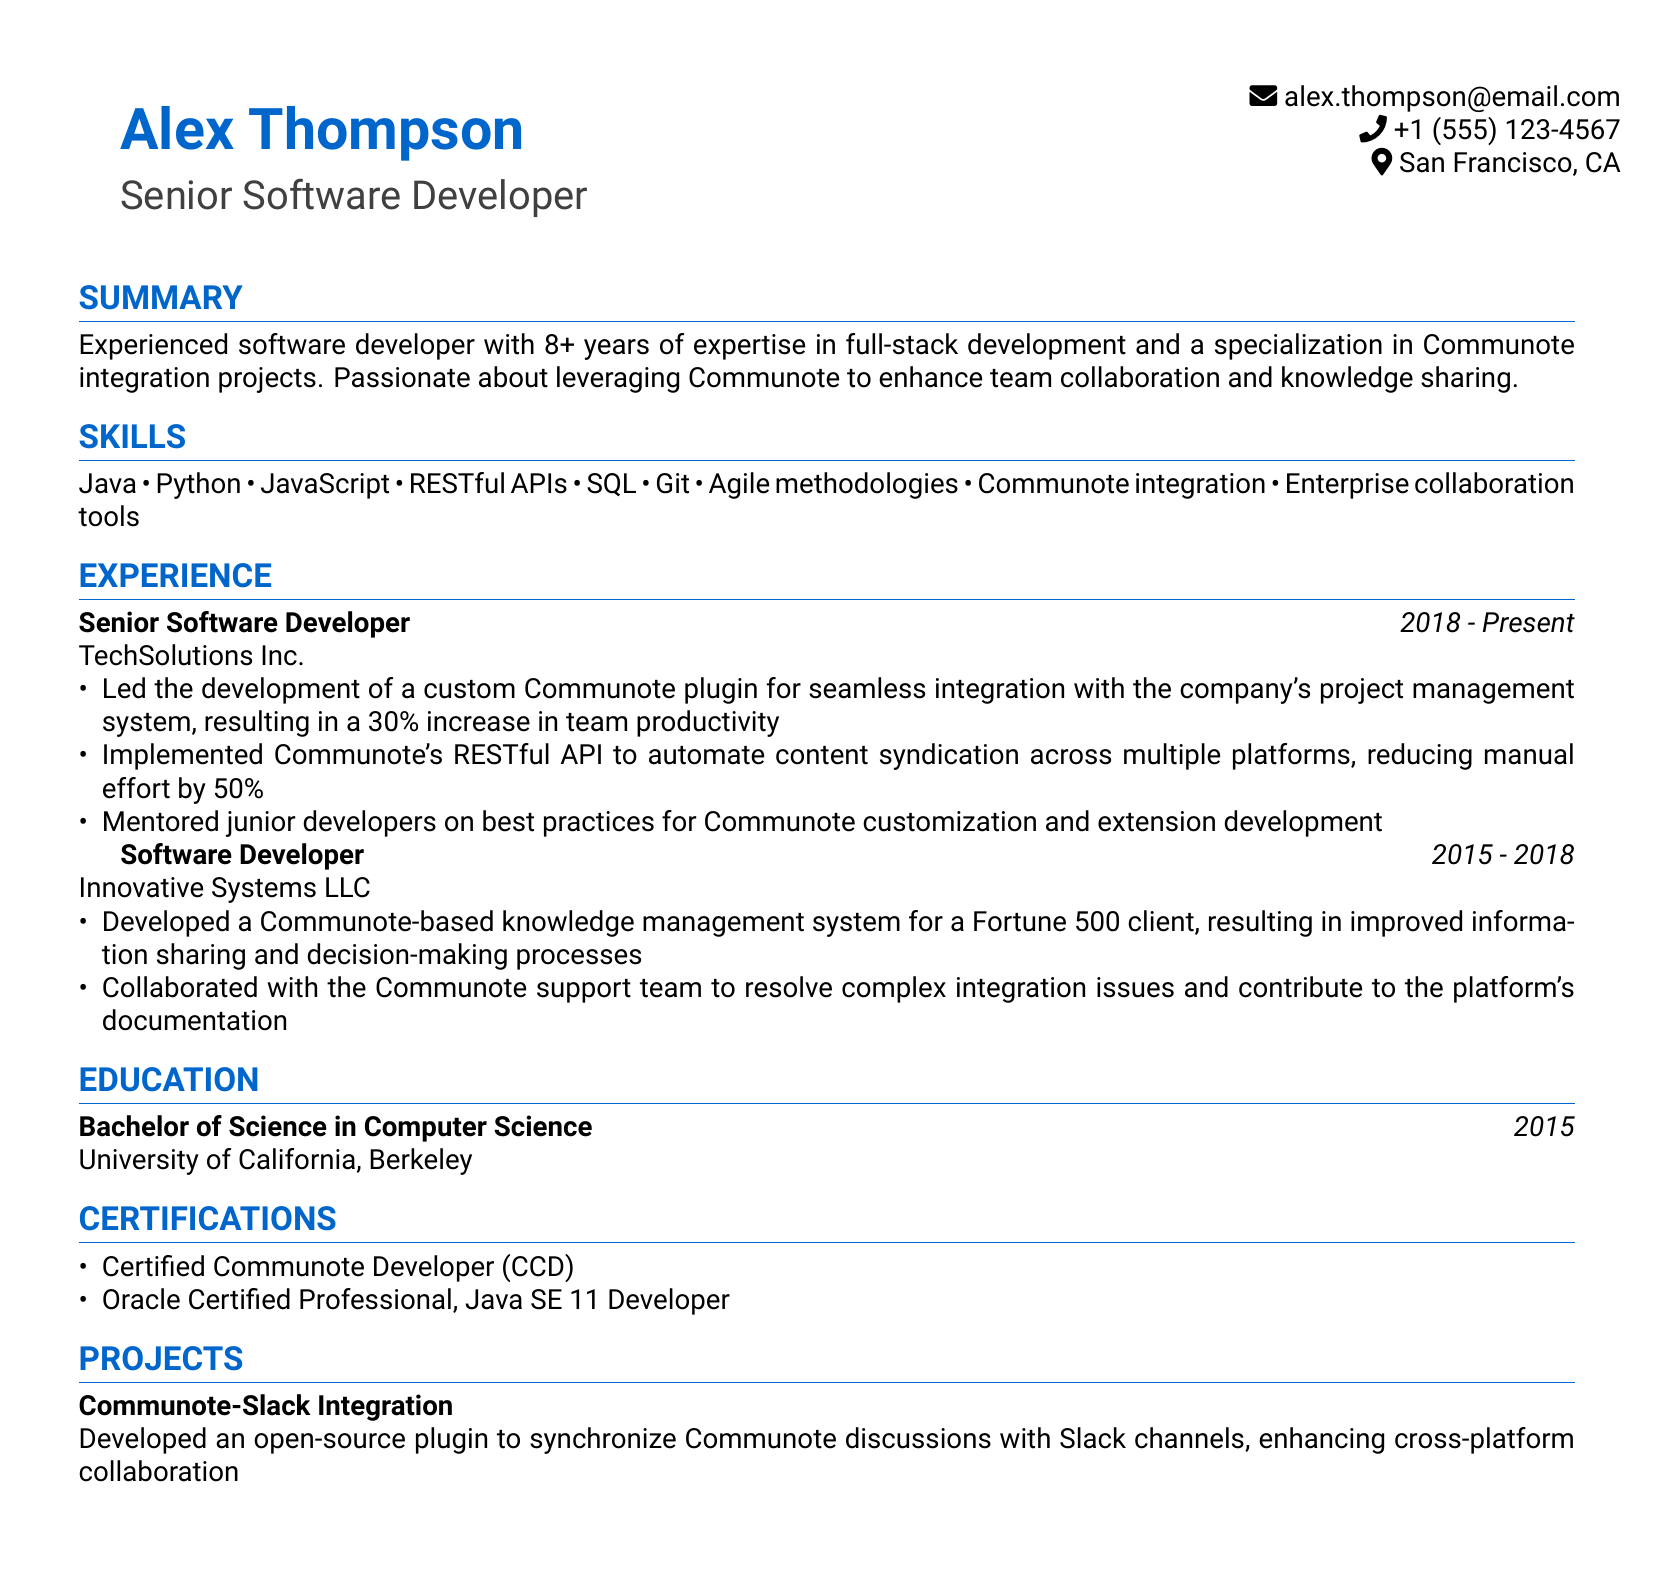What is the name of the individual? The name of the individual is listed at the top of the document.
Answer: Alex Thompson What is the title of the CV? The title reflects the individual's professional position and is indicated below the name.
Answer: Senior Software Developer How many years of experience does Alex have? The summary section states the years of expertise Alex possesses in the industry.
Answer: 8+ What company does Alex currently work for? The experience section lists the current employer in the first entry.
Answer: TechSolutions Inc What was the duration of Alex's previous job? The experience section provides the period Alex worked at the prior company.
Answer: 2015 - 2018 What is one of the certifications Alex holds? The certifications section lists various qualifications Alex has achieved.
Answer: Certified Communote Developer (CCD) What project did Alex develop related to Communote? The projects section highlights significant work performed by Alex.
Answer: Communote-Slack Integration What programming languages is Alex skilled in? The skills section enumerates the programming languages Alex is proficient in.
Answer: Java, Python, JavaScript What integration does Alex specialize in? The summary section specifically indicates a focus area of expertise.
Answer: Communote integration 